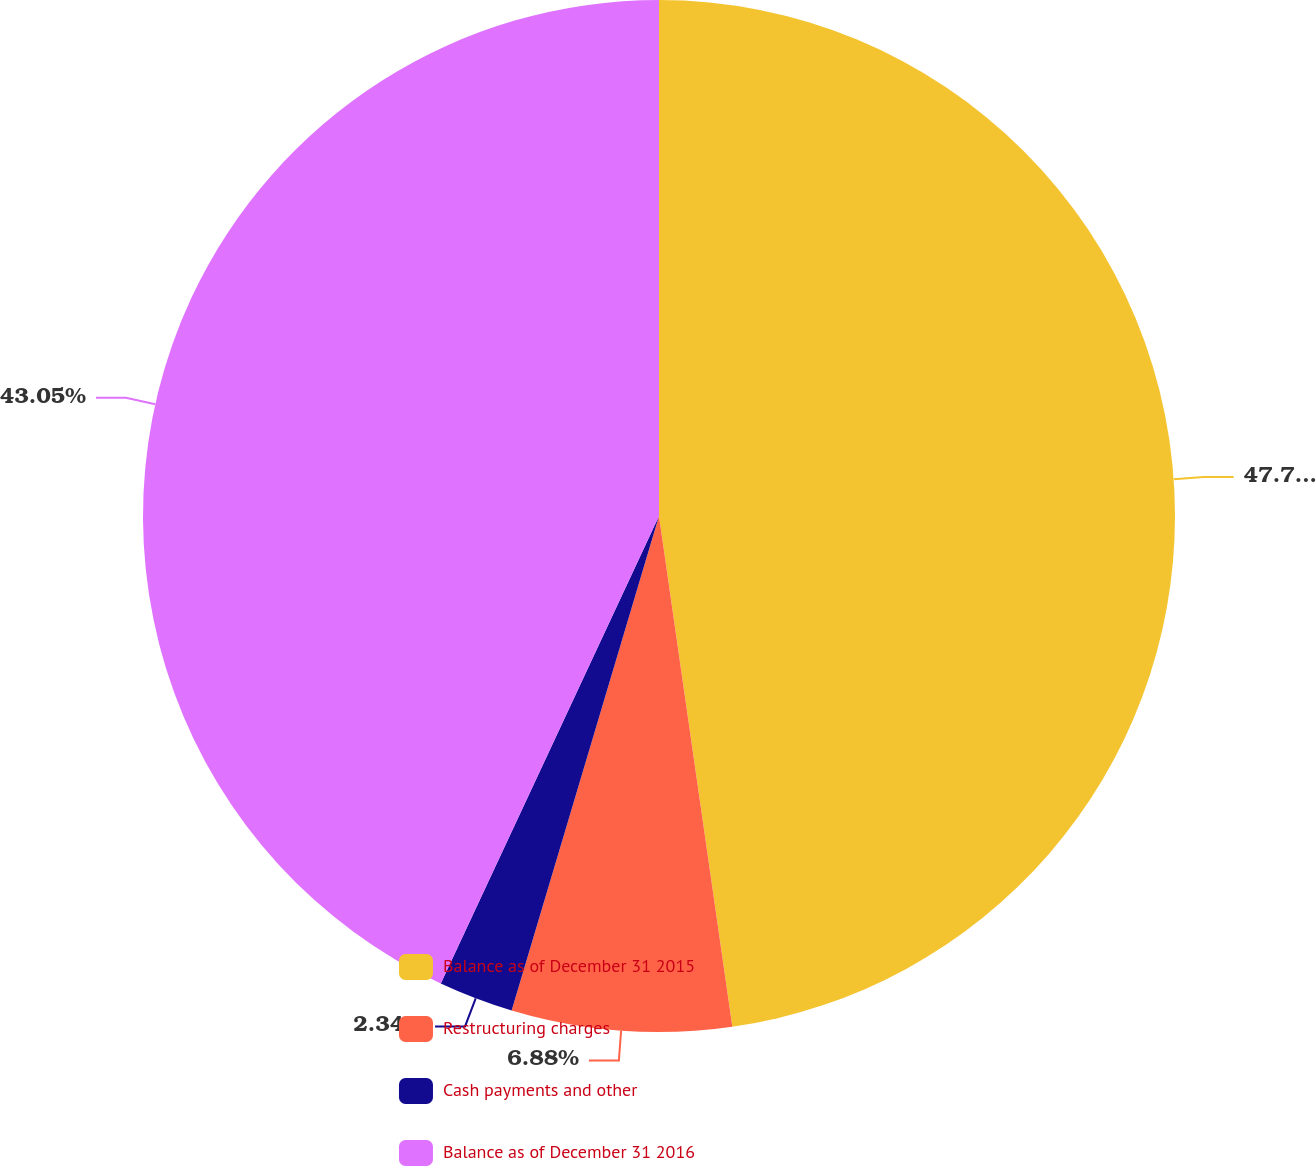Convert chart. <chart><loc_0><loc_0><loc_500><loc_500><pie_chart><fcel>Balance as of December 31 2015<fcel>Restructuring charges<fcel>Cash payments and other<fcel>Balance as of December 31 2016<nl><fcel>47.73%<fcel>6.88%<fcel>2.34%<fcel>43.05%<nl></chart> 